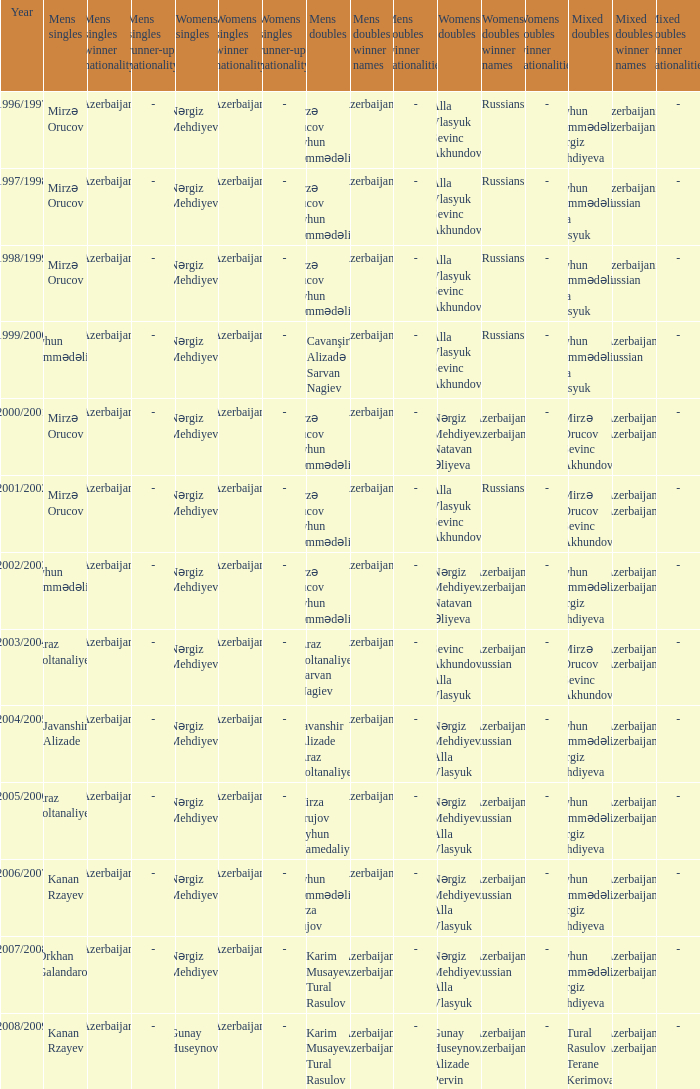Who are all the womens doubles for the year 2008/2009? Gunay Huseynova Alizade Pervin. 